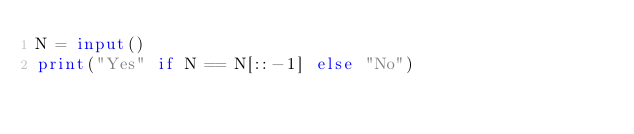Convert code to text. <code><loc_0><loc_0><loc_500><loc_500><_Python_>N = input()
print("Yes" if N == N[::-1] else "No")</code> 